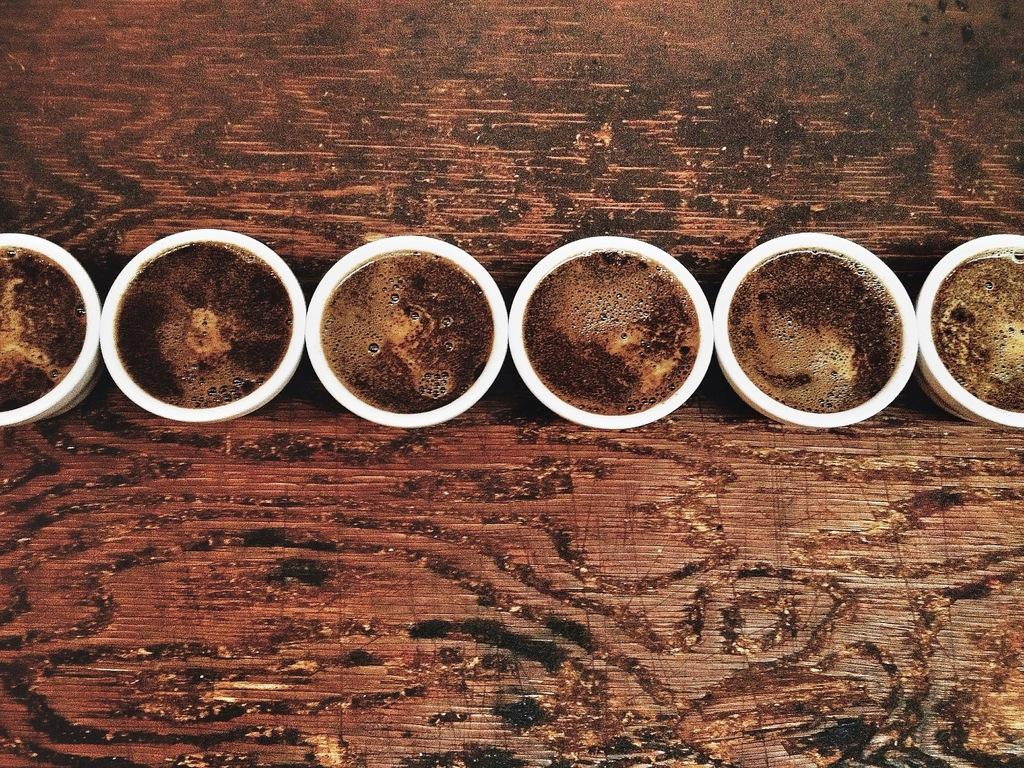What objects are present in the image? There are cups in the image. Where are the cups located? The cups are on a wooden table. Can you see a rabbit touching the camera in the image? There is no camera or rabbit present in the image. 